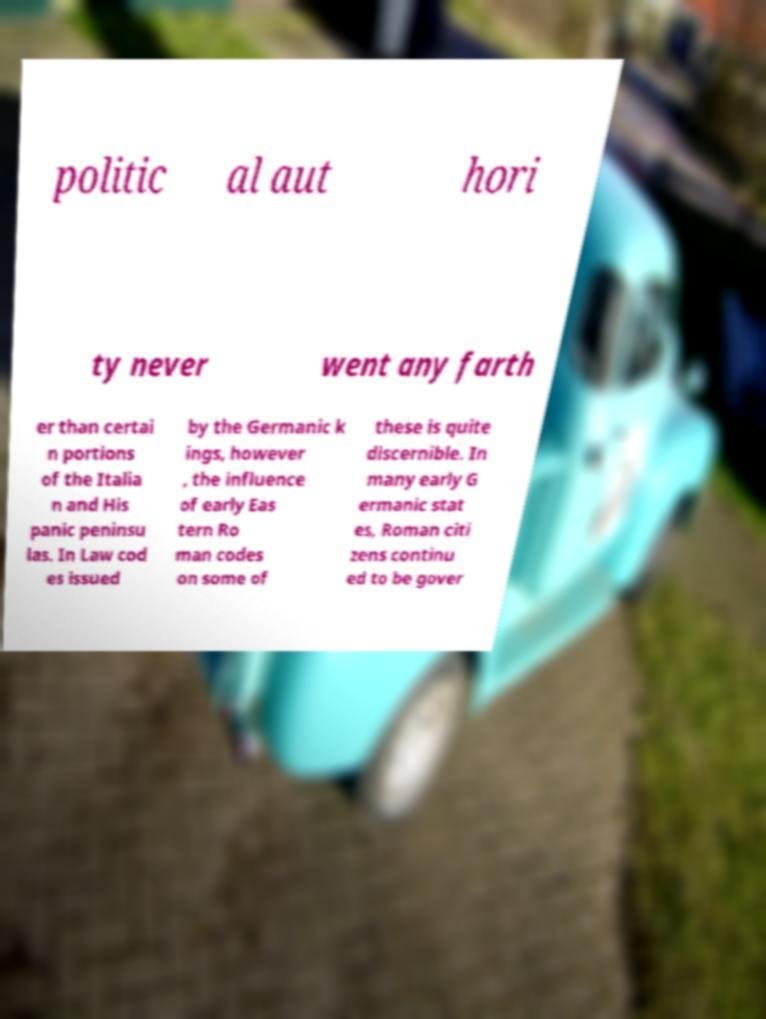What messages or text are displayed in this image? I need them in a readable, typed format. politic al aut hori ty never went any farth er than certai n portions of the Italia n and His panic peninsu las. In Law cod es issued by the Germanic k ings, however , the influence of early Eas tern Ro man codes on some of these is quite discernible. In many early G ermanic stat es, Roman citi zens continu ed to be gover 